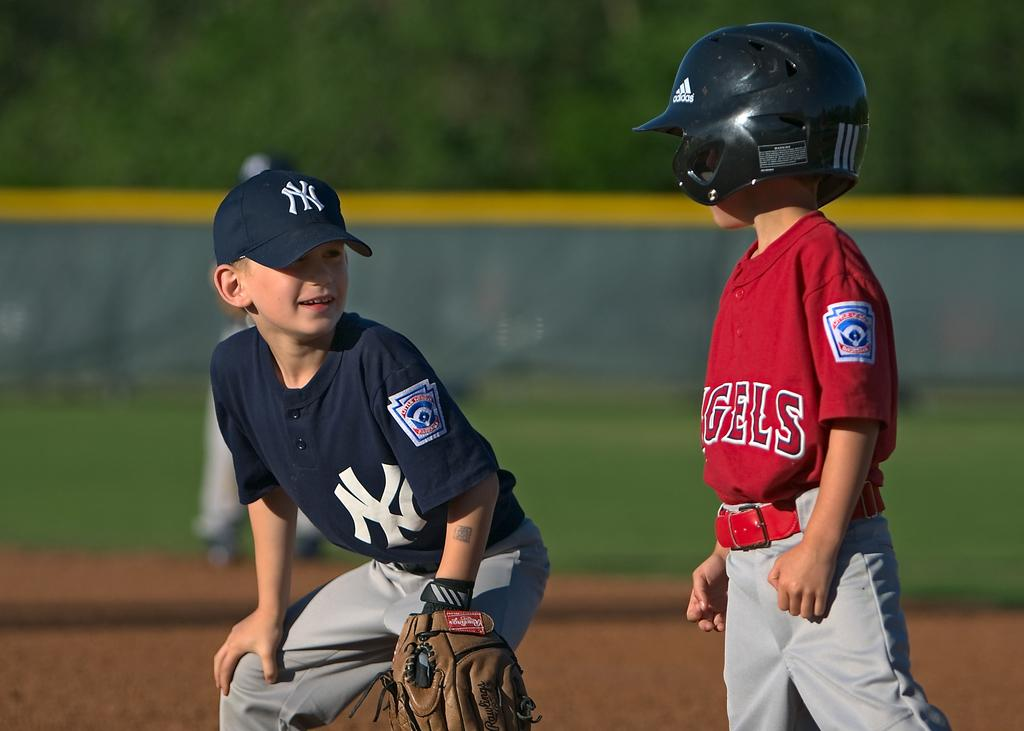What is the main subject of the image? The main subjects of the image are a kid and a boy. What is the kid wearing in the image? The kid is wearing a helmet in the image. How is the boy positioned in the image? The boy is sitting in a squat position in the image. What accessories is the boy wearing in the image? The boy is wearing a cap and gloves in the image. What colors can be seen in the background of the image? The background of the image has blue and green colors. Is the room in the image comfortable for the kid and the boy? The image does not show a room, so it is not possible to determine the comfort level of the space. Why is the boy crying in the image? There is no indication in the image that the boy is crying; he is sitting in a squat position with a cap and gloves on. 